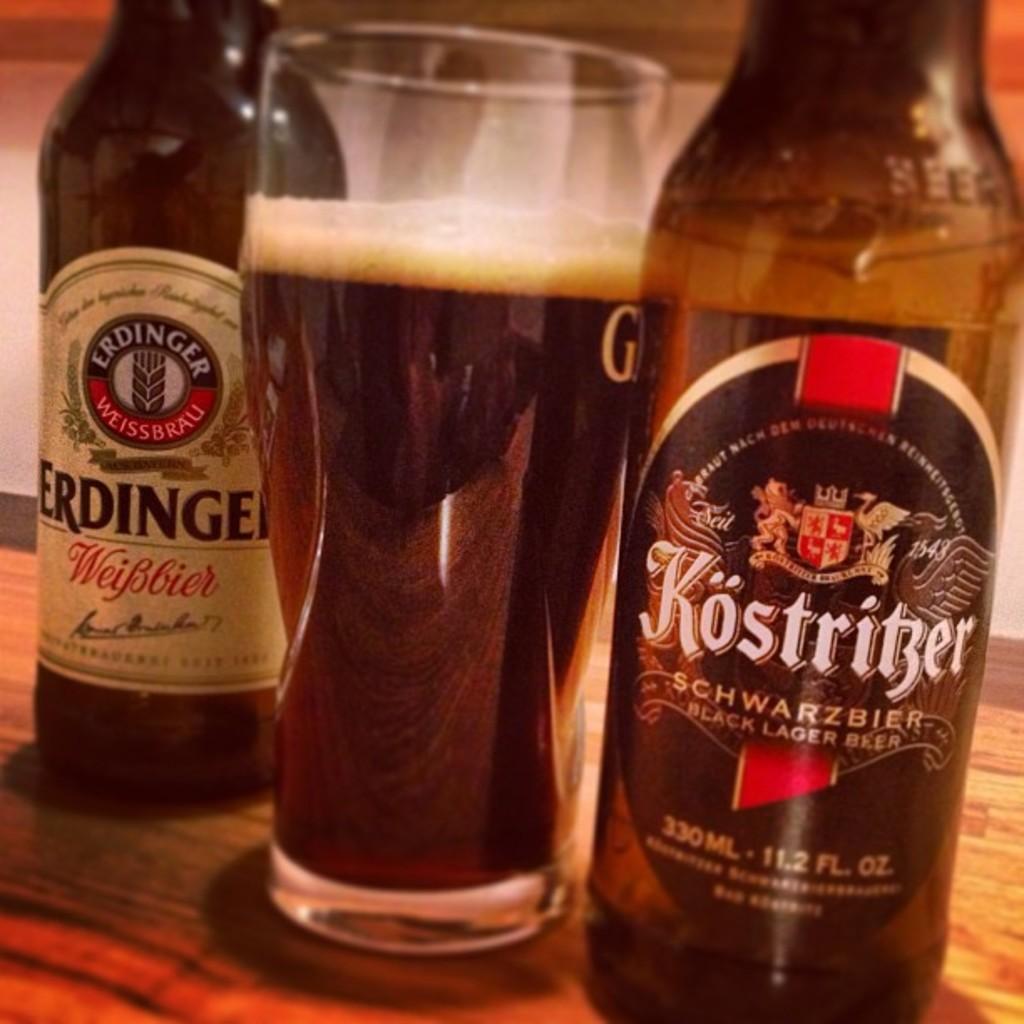Is the glass almost full in the picture?
Offer a very short reply. Answering does not require reading text in the image. What brand of beer is the bottle on the right?
Make the answer very short. Kostritzer. 